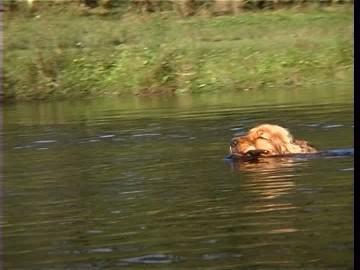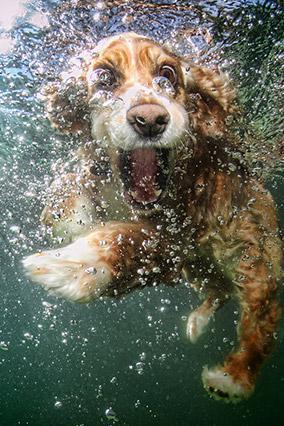The first image is the image on the left, the second image is the image on the right. Evaluate the accuracy of this statement regarding the images: "One tennis ball is in both images.". Is it true? Answer yes or no. No. The first image is the image on the left, the second image is the image on the right. Given the left and right images, does the statement "In one of the images, there is a dog swimming while carrying an object in its mouth." hold true? Answer yes or no. Yes. 